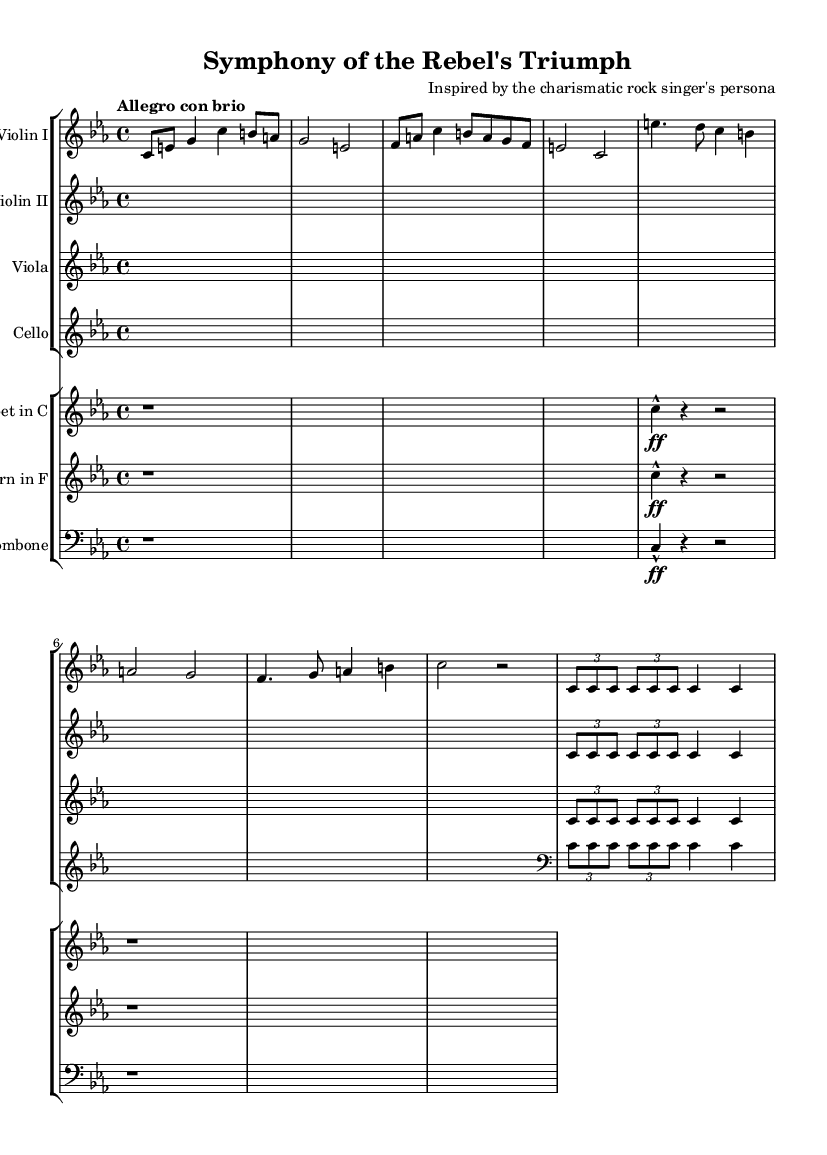What is the key signature of this music? The key signature is indicated in the beginning of the sheet music, showing no sharps or flats, which corresponds to C minor.
Answer: C minor What is the time signature of this piece? The time signature is located next to the key signature at the beginning of the score, which indicates that there are four beats in a measure and the quarter note gets the beat.
Answer: 4/4 What is the tempo marking for this symphony? The tempo marking is found at the start of the piece, indicating the speed at which the symphony should be played, described as "Allegro con brio," which means lively and with spirit.
Answer: Allegro con brio How many main themes are presented in the piece? By analyzing the structure of the music, one will recognize that it includes a distinct main theme followed by a secondary theme; thus, there are two main themes presented.
Answer: 2 What instruments are part of the first staff group? The first staff group lists the instruments played by strings, most notably the Violin I, Violin II, Viola, and Cello, which can be found in their respective staves in the score.
Answer: Violin I, Violin II, Viola, Cello What rhythmic motif is repeated throughout this symphony? Closely examining the music, the rhythmic motif consists of a specific repeated sequence that can be identified within the sections assigned to the violins, viola, and cello.
Answer: c8 c8 c4 Which brass instruments feature in the second staff group? The second staff group reveals the brass instruments used, which includes the Trumpet in C, Horn in F, and Trombone, as indicated by their respective staves in the score.
Answer: Trumpet, Horn, Trombone 